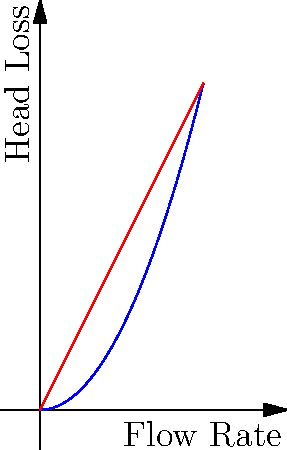Based on the graph comparing head loss versus flow rate in ancient aqueduct systems and modern water distribution networks, which system experiences a more rapid increase in head loss as flow rate increases? How does this difference impact the efficiency of water distribution in each system? To answer this question, we need to analyze the graph and understand the relationship between head loss and flow rate for both systems:

1. Ancient Aqueduct (blue curve):
   - The curve is parabolic, represented by the equation $h = 0.5Q^2$, where $h$ is head loss and $Q$ is flow rate.
   - As flow rate increases, head loss increases exponentially.

2. Modern Network (red line):
   - The relationship is linear, represented by the equation $h = 2Q$.
   - As flow rate increases, head loss increases linearly.

3. Comparing the two systems:
   - At low flow rates, the modern network experiences higher head loss.
   - As flow rate increases, the ancient aqueduct's head loss surpasses that of the modern network.
   - The ancient aqueduct's curve becomes steeper than the modern network's line.

4. Impact on efficiency:
   - In ancient aqueducts, the rapid increase in head loss at higher flow rates limits the system's capacity to deliver water efficiently over long distances.
   - Modern networks maintain a more consistent relationship between head loss and flow rate, allowing for better control and predictability in water distribution.
   - The linear relationship in modern systems enables easier calculation and management of pumping requirements across various flow rates.

5. Conclusion:
   - The ancient aqueduct system experiences a more rapid increase in head loss as flow rate increases.
   - This difference makes modern water distribution networks more efficient and adaptable to varying water demands compared to ancient aqueduct systems.
Answer: Ancient aqueduct; modern networks are more efficient due to linear head loss-flow rate relationship. 